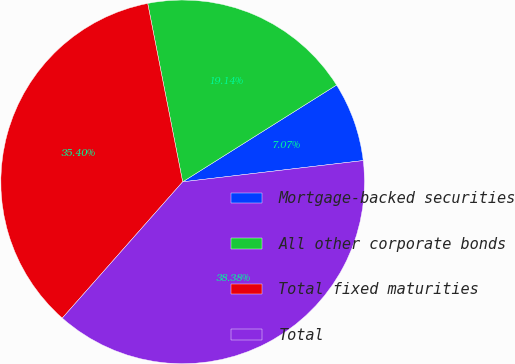Convert chart to OTSL. <chart><loc_0><loc_0><loc_500><loc_500><pie_chart><fcel>Mortgage-backed securities<fcel>All other corporate bonds<fcel>Total fixed maturities<fcel>Total<nl><fcel>7.07%<fcel>19.14%<fcel>35.4%<fcel>38.38%<nl></chart> 